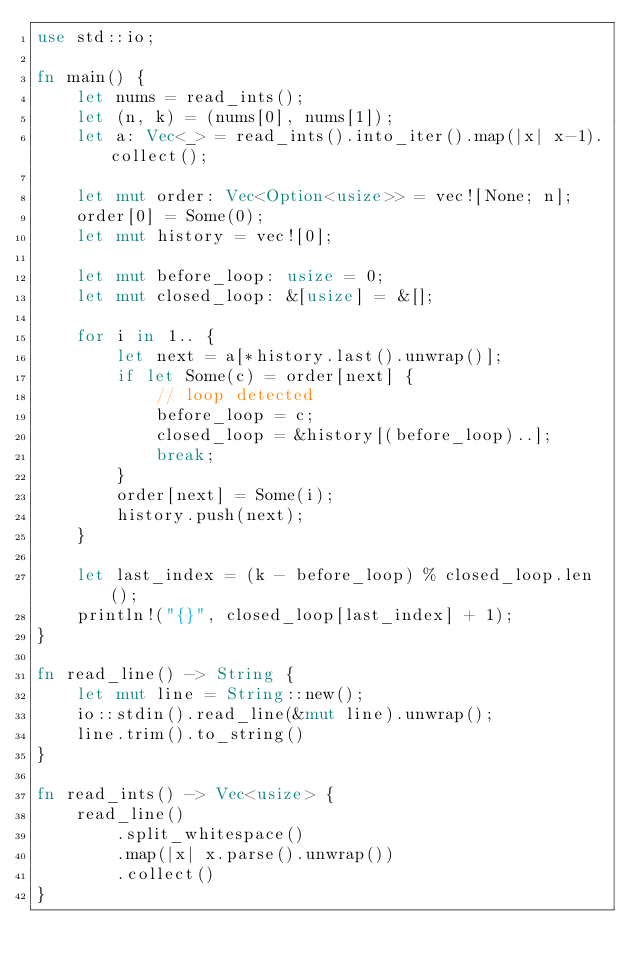<code> <loc_0><loc_0><loc_500><loc_500><_Rust_>use std::io;

fn main() {
    let nums = read_ints();
    let (n, k) = (nums[0], nums[1]);
    let a: Vec<_> = read_ints().into_iter().map(|x| x-1).collect();

    let mut order: Vec<Option<usize>> = vec![None; n];
    order[0] = Some(0);
    let mut history = vec![0];
    
    let mut before_loop: usize = 0;
    let mut closed_loop: &[usize] = &[];

    for i in 1.. {
        let next = a[*history.last().unwrap()];
        if let Some(c) = order[next] {
            // loop detected
            before_loop = c;
            closed_loop = &history[(before_loop)..];
            break;
        }
        order[next] = Some(i);
        history.push(next);
    }

    let last_index = (k - before_loop) % closed_loop.len();
    println!("{}", closed_loop[last_index] + 1);
}

fn read_line() -> String {
    let mut line = String::new();
    io::stdin().read_line(&mut line).unwrap();
    line.trim().to_string()
}

fn read_ints() -> Vec<usize> {
    read_line()
        .split_whitespace()
        .map(|x| x.parse().unwrap())
        .collect()
}
</code> 